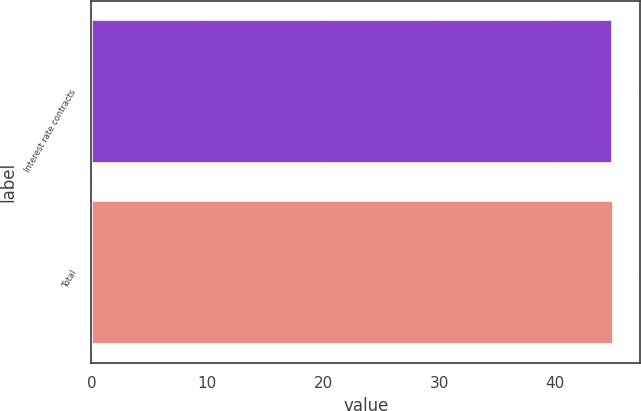Convert chart to OTSL. <chart><loc_0><loc_0><loc_500><loc_500><bar_chart><fcel>Interest rate contracts<fcel>Total<nl><fcel>45<fcel>45.1<nl></chart> 